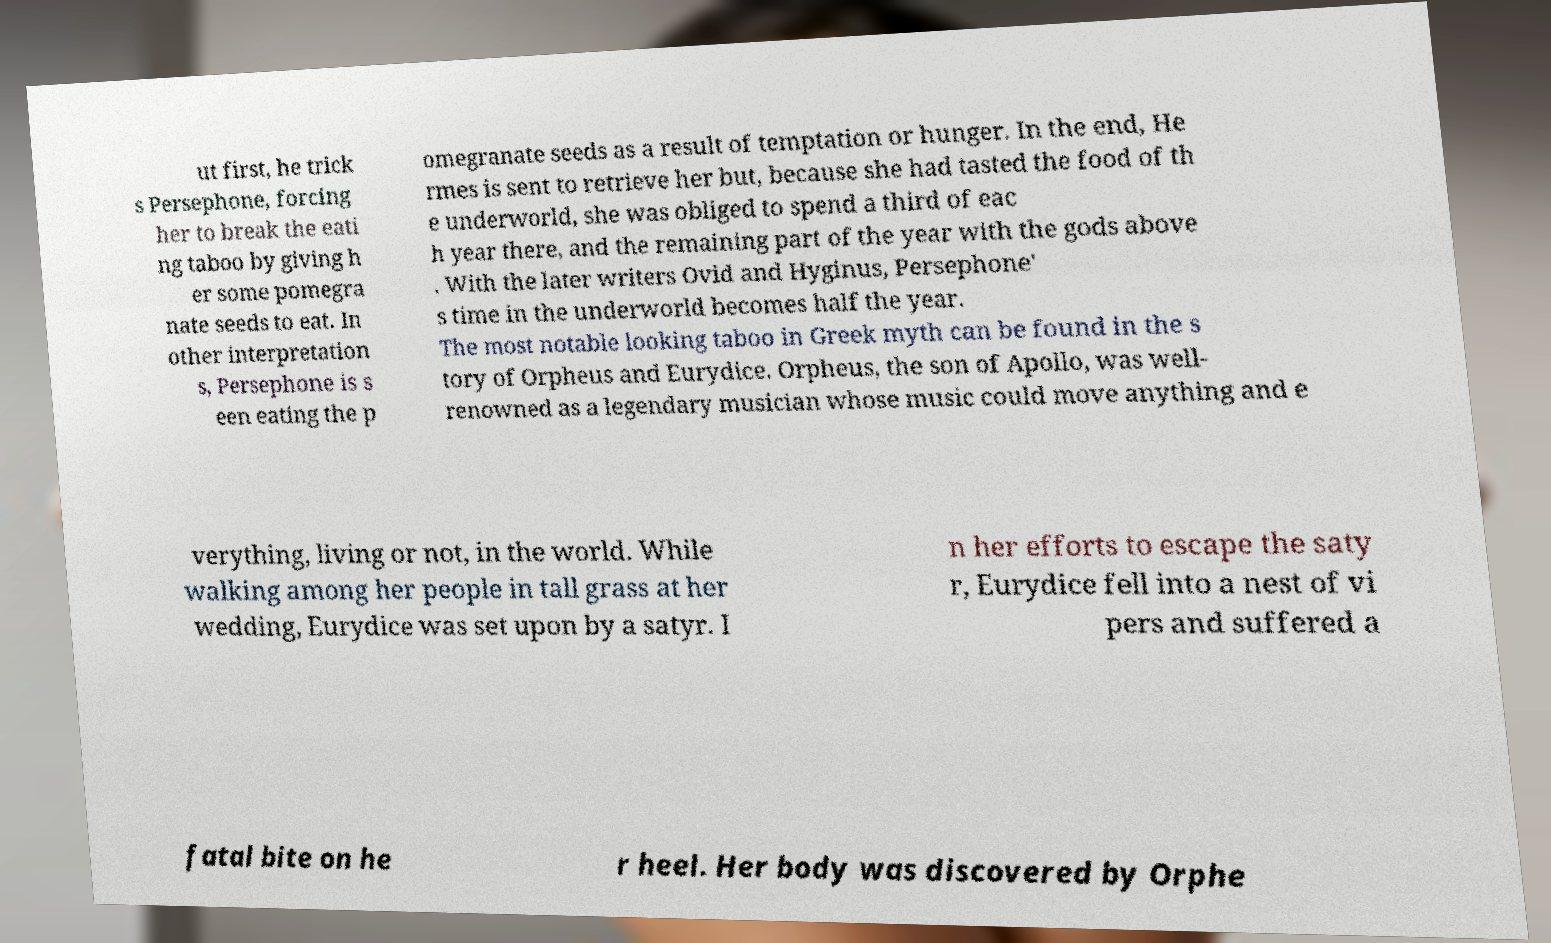Please read and relay the text visible in this image. What does it say? ut first, he trick s Persephone, forcing her to break the eati ng taboo by giving h er some pomegra nate seeds to eat. In other interpretation s, Persephone is s een eating the p omegranate seeds as a result of temptation or hunger. In the end, He rmes is sent to retrieve her but, because she had tasted the food of th e underworld, she was obliged to spend a third of eac h year there, and the remaining part of the year with the gods above . With the later writers Ovid and Hyginus, Persephone' s time in the underworld becomes half the year. The most notable looking taboo in Greek myth can be found in the s tory of Orpheus and Eurydice. Orpheus, the son of Apollo, was well- renowned as a legendary musician whose music could move anything and e verything, living or not, in the world. While walking among her people in tall grass at her wedding, Eurydice was set upon by a satyr. I n her efforts to escape the saty r, Eurydice fell into a nest of vi pers and suffered a fatal bite on he r heel. Her body was discovered by Orphe 